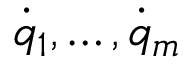Convert formula to latex. <formula><loc_0><loc_0><loc_500><loc_500>{ \dot { q } } _ { 1 } , \dots , { \dot { q } } _ { m }</formula> 